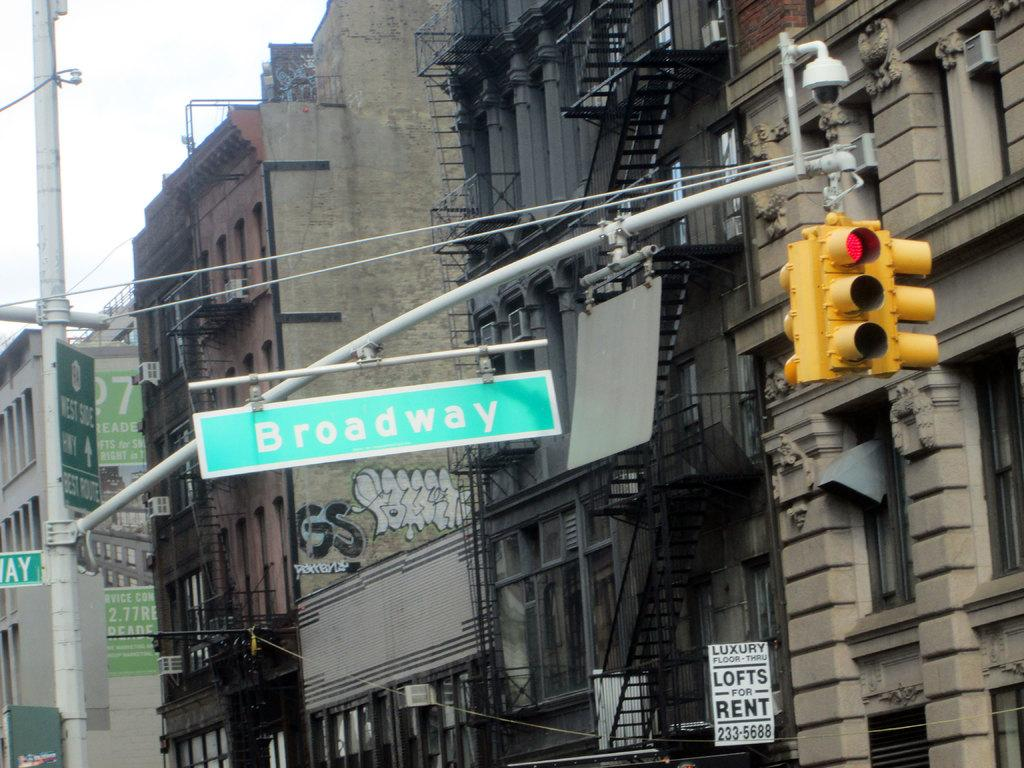<image>
Present a compact description of the photo's key features. A street sign next to a traffic light reads Broadway. 